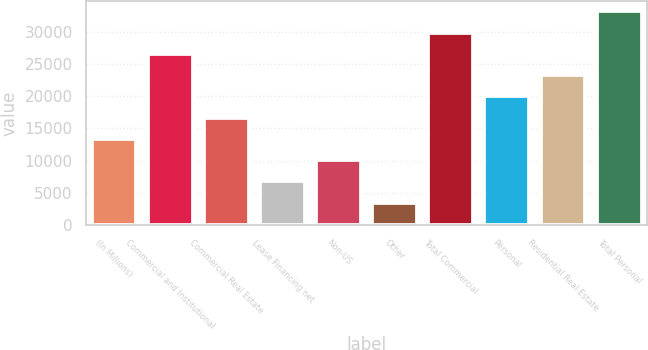<chart> <loc_0><loc_0><loc_500><loc_500><bar_chart><fcel>(In Millions)<fcel>Commercial and Institutional<fcel>Commercial Real Estate<fcel>Lease Financing net<fcel>Non-US<fcel>Other<fcel>Total Commercial<fcel>Personal<fcel>Residential Real Estate<fcel>Total Personal<nl><fcel>13388.6<fcel>26583.5<fcel>16687.3<fcel>6791.22<fcel>10089.9<fcel>3492.51<fcel>29882.2<fcel>19986.1<fcel>23284.8<fcel>33180.9<nl></chart> 